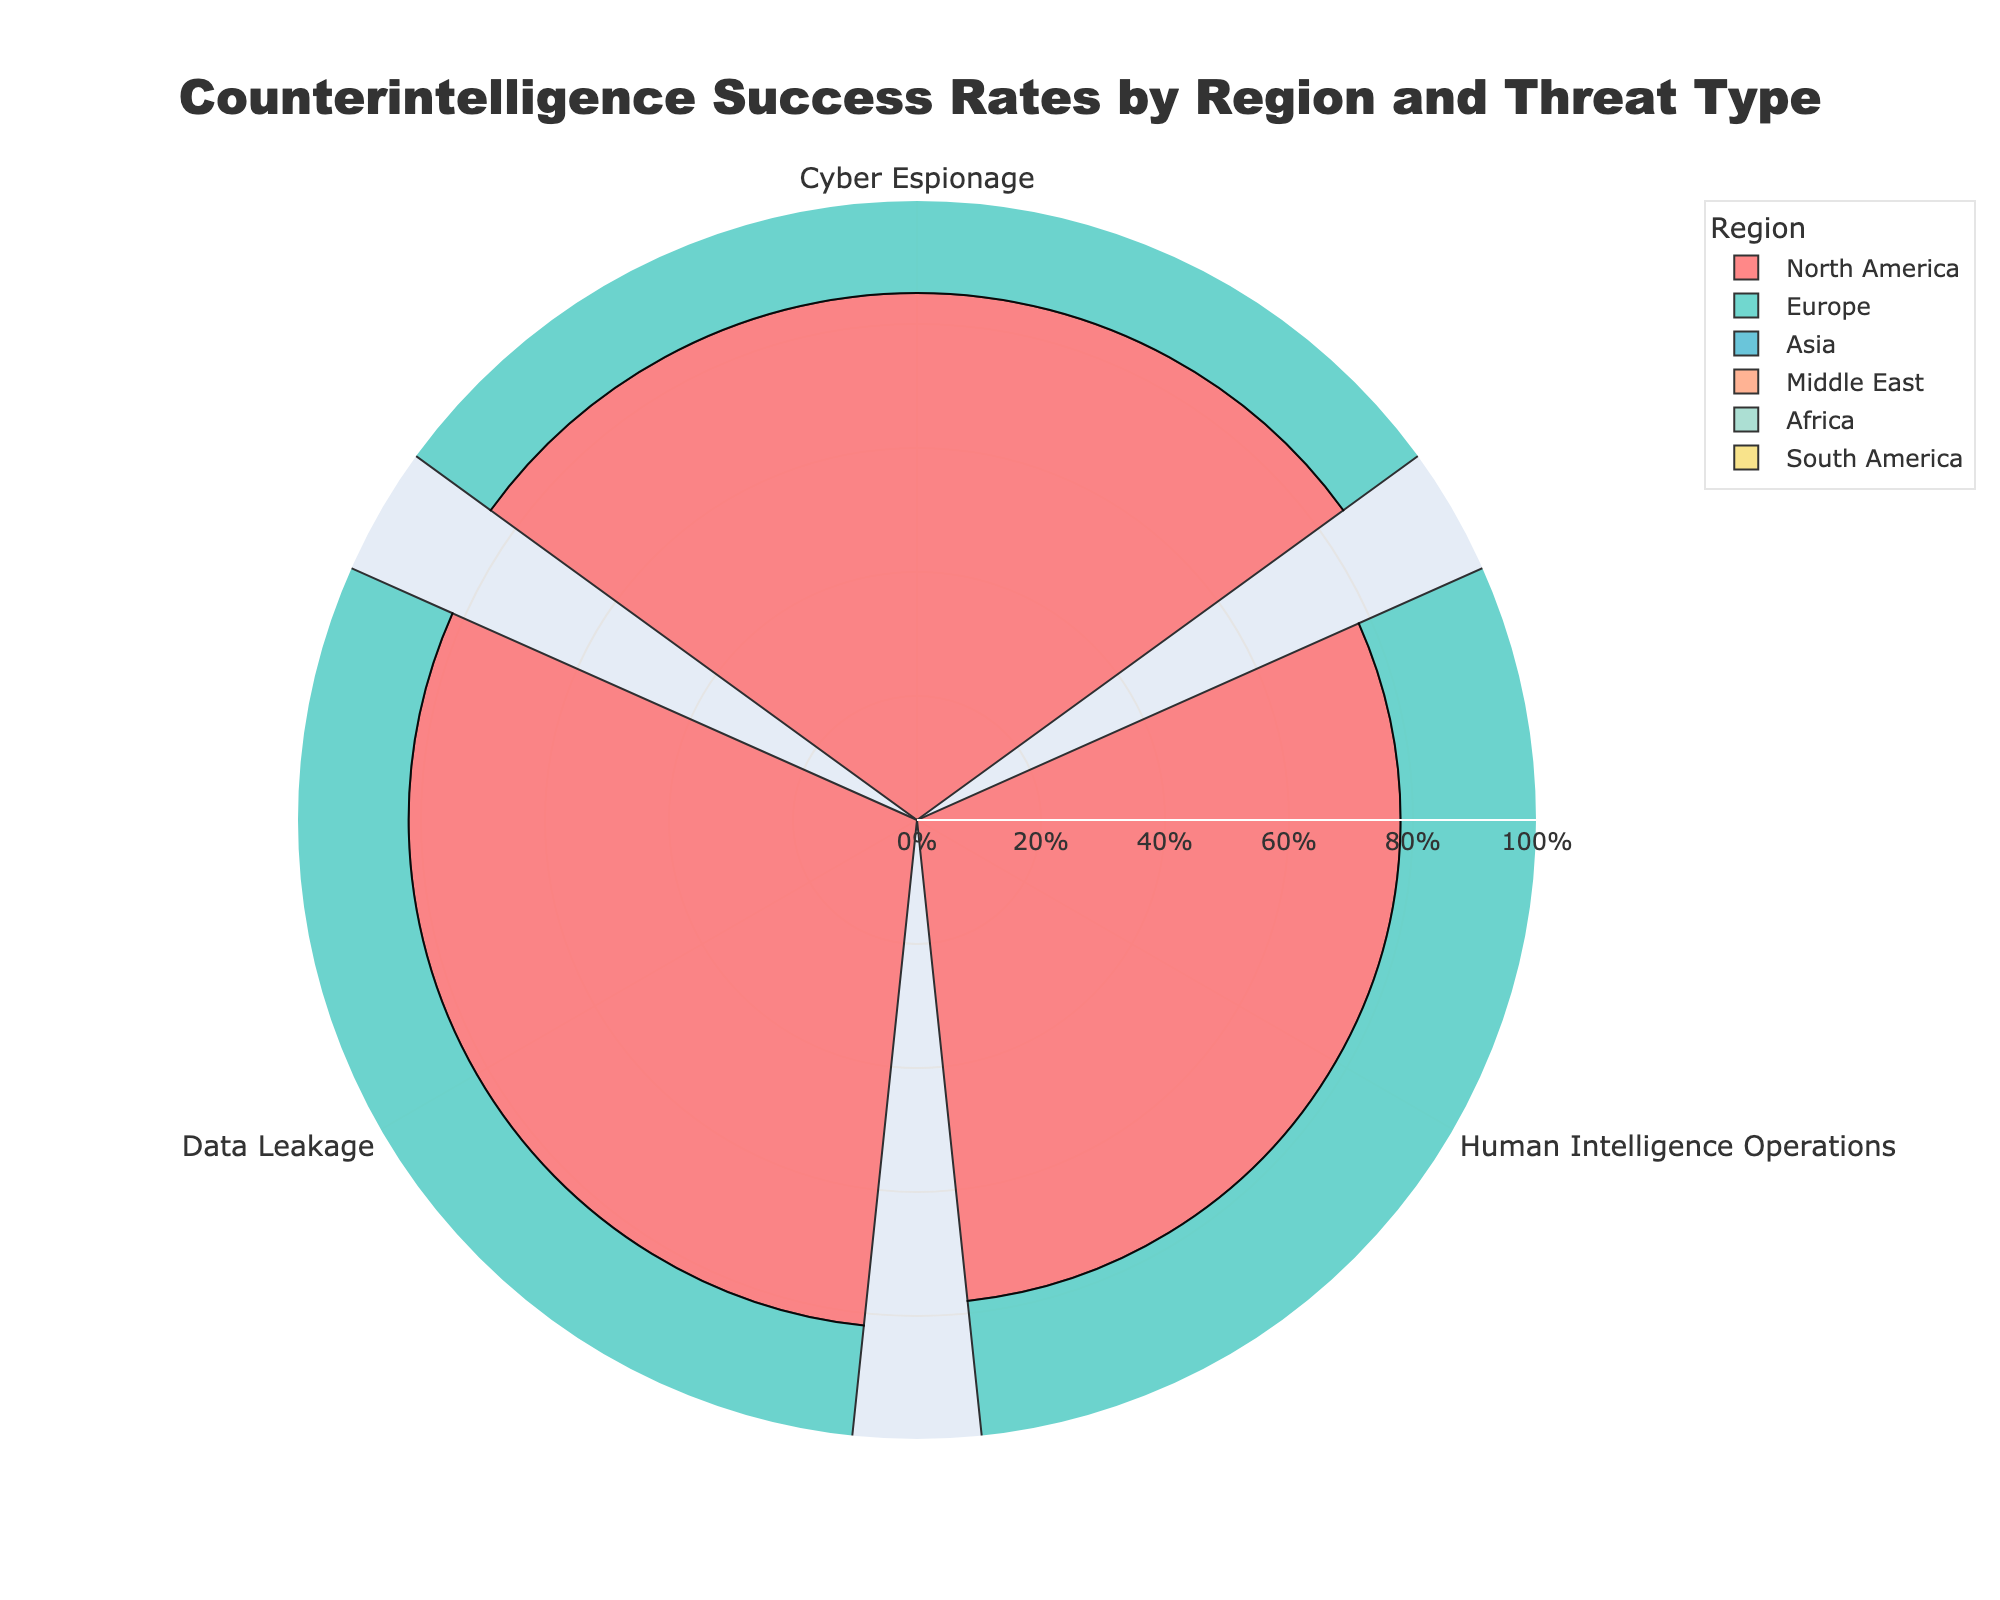Which region has the highest success rate for Cyber Espionage? From the rose chart, look for the bar labeled "Cyber Espionage" and identify the region with the longest bar. The longest bar for "Cyber Espionage" is labeled for Asia.
Answer: Asia What is the title of the chart? The title is usually prominently displayed at the top of the chart. The title of this chart is "Counterintelligence Success Rates by Region and Threat Type."
Answer: Counterintelligence Success Rates by Region and Threat Type Which region has the lowest success rate for Data Leakage? Locate the bars labeled "Data Leakage" and identify the shortest one. The shortest bar for "Data Leakage" is labeled for the Middle East.
Answer: Middle East What is the average success rate for Human Intelligence Operations across all regions? Look at the bars labeled "Human Intelligence Operations" for each region: North America (78), Europe (76), Asia (81), Middle East (73), Africa (77), and South America (74). Calculate the average: (78 + 76 + 81 + 73 + 77 + 74) / 6 = 459 / 6 = 76.5.
Answer: 76.5 Compare the success rates of Cyber Espionage in North America and Europe. Which is higher? Compare the lengths of the bars labeled "Cyber Espionage" for North America and Europe. North America's bar is longer, indicating a higher success rate.
Answer: North America Do the success rates for Data Leakage fluctuate significantly between regions? Examine the bars labeled "Data Leakage" for each region. They range from 70% (Middle East) to 84% (Asia), indicating some variation but not extreme.
Answer: Yes How many different threat types are represented in the chart? Count the unique labels along the angular axis, which represent different threat types: Cyber Espionage, Human Intelligence Operations, and Data Leakage.
Answer: 3 What is the success rate for Human Intelligence Operations in Africa? Locate the bar labeled "Human Intelligence Operations" for the region "Africa." The bar is marked at 77%.
Answer: 77% Which region has the most balanced success rates across all three threat types? Review the lengths of bars within each region. North America and Asia have relatively balanced success rates across Cyber Espionage, Human Intelligence Operations, and Data Leakage. Upon closer examination, Asia seems slightly more balanced.
Answer: Asia Is there any region where the success rate for one threat significantly outperforms the others? Identify regions where the length of one bar is notably longer than the others. In the chart, Asia's success rate for Cyber Espionage (88%) is significantly higher compared to its other threat types.
Answer: Asia 